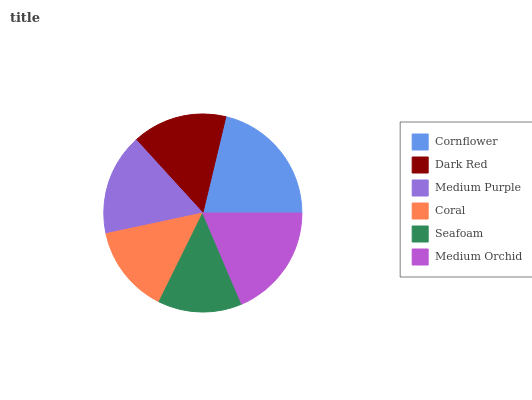Is Seafoam the minimum?
Answer yes or no. Yes. Is Cornflower the maximum?
Answer yes or no. Yes. Is Dark Red the minimum?
Answer yes or no. No. Is Dark Red the maximum?
Answer yes or no. No. Is Cornflower greater than Dark Red?
Answer yes or no. Yes. Is Dark Red less than Cornflower?
Answer yes or no. Yes. Is Dark Red greater than Cornflower?
Answer yes or no. No. Is Cornflower less than Dark Red?
Answer yes or no. No. Is Medium Purple the high median?
Answer yes or no. Yes. Is Dark Red the low median?
Answer yes or no. Yes. Is Cornflower the high median?
Answer yes or no. No. Is Cornflower the low median?
Answer yes or no. No. 